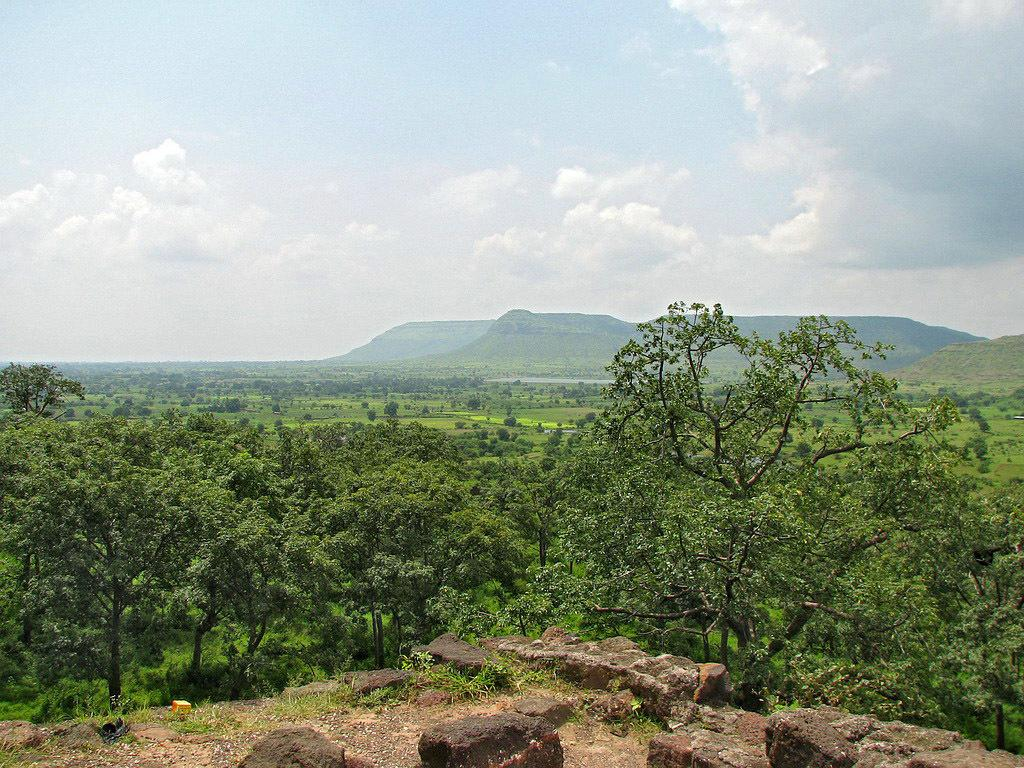What type of natural features can be seen in the image? There are trees, rocks, and fields visible in the image. What type of landscape is depicted in the background of the image? There are mountains in the background of the image. What is visible in the sky at the top of the image? There are clouds in the sky at the top of the image. How many dogs can be seen playing with a pencil in the image? There are no dogs or pencils present in the image. What type of bird is sitting on the robin in the image? There is no robin present in the image. 